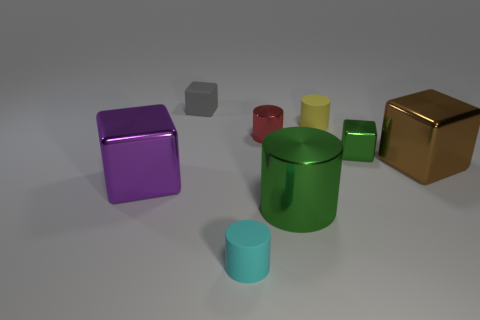How many blocks are small red things or gray things?
Offer a very short reply. 1. Are there any other things of the same color as the large cylinder?
Offer a terse response. Yes. What is the cube behind the small rubber object that is right of the green shiny cylinder made of?
Keep it short and to the point. Rubber. Is the material of the brown thing the same as the big cube that is to the left of the small yellow matte cylinder?
Your answer should be very brief. Yes. What number of things are either blocks that are left of the large green metallic object or cylinders?
Offer a very short reply. 6. Are there any metal blocks of the same color as the large metal cylinder?
Your answer should be very brief. Yes. Is the shape of the cyan matte thing the same as the object right of the small green cube?
Your response must be concise. No. What number of things are left of the yellow object and in front of the tiny yellow rubber cylinder?
Ensure brevity in your answer.  4. There is a big purple thing that is the same shape as the tiny green shiny thing; what material is it?
Ensure brevity in your answer.  Metal. There is a green object behind the big shiny cube left of the gray rubber object; how big is it?
Ensure brevity in your answer.  Small. 